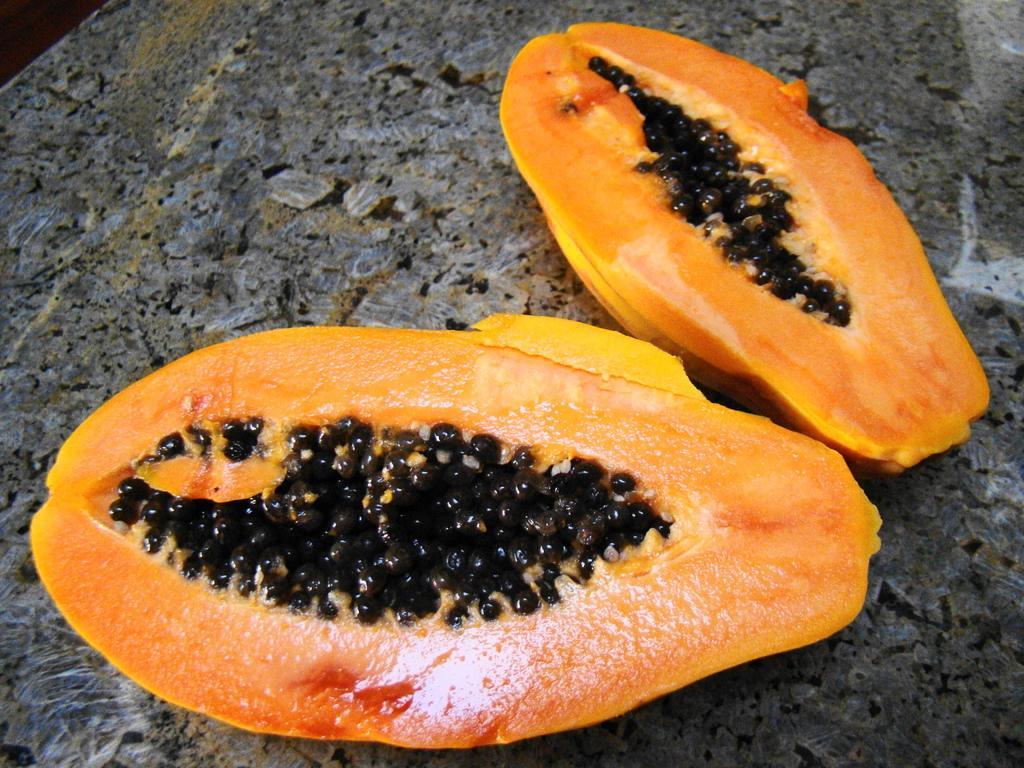In one or two sentences, can you explain what this image depicts? This picture shows papaya divided into two equal halves on the table. We see seeds. 